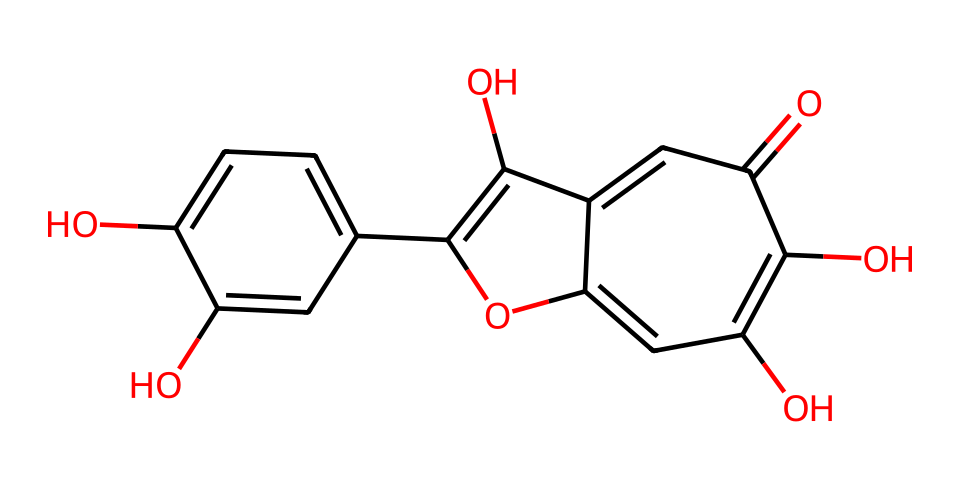What is the total number of carbon atoms in quercetin? Inspecting the SMILES representation, we can identify the number of carbon atoms by counting the 'C' symbols. In this case, there are 15 carbon atoms present in the structure.
Answer: 15 How many hydroxyl (–OH) groups are present in quercetin? Looking at the structure, we observe the presence of –OH groups. From the chemical formula, we can see there are 5 hydroxyl groups in total.
Answer: 5 What is the primary functional group in quercetin that contributes to its antioxidant properties? In the chemical structure, the presence of hydroxyl groups (–OH) is significant, as these groups are known to donate electrons and neutralize free radicals, which is key to its antioxidant activity.
Answer: hydroxyl Which type of compound is quercetin classified as? Based on the structure and its known properties, quercetin is classified as a flavonoid, which is a type of polyphenolic compound found in many fruits and vegetables.
Answer: flavonoid What is the molecular formula of quercetin? To derive the molecular formula from the SMILES, we combine the counts of all atoms: 15 carbons (C), 10 hydrogens (H), and 7 oxygens (O), leading to a formula of C15H10O7.
Answer: C15H10O7 How many rings are present in the structure of quercetin? By analyzing the structure, we can identify that there are three fused ring structures (connected cyclic structures) present in the quercetin molecule.
Answer: 3 What type of bonding is primarily found in quercetin, contributing to its stability? Observing the structure, we find that quercetin has both single (C-C) and double (C=C) bonding. The presence of these stable carbon-carbon bonds contributes significantly to its overall stability.
Answer: covalent bonds 